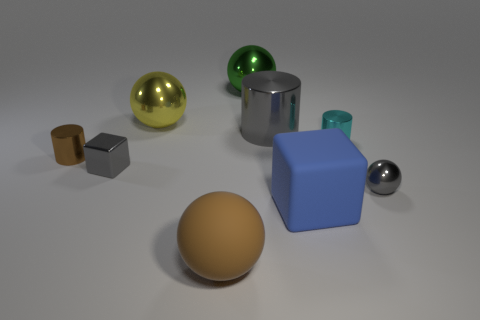There is a sphere that is the same color as the large shiny cylinder; what size is it?
Keep it short and to the point. Small. There is a small metallic ball; is its color the same as the cylinder to the left of the green metallic object?
Offer a very short reply. No. What number of things are either objects right of the gray metallic cube or metallic balls in front of the yellow object?
Provide a succinct answer. 7. There is a tiny gray metallic thing on the right side of the tiny cylinder that is behind the brown metallic cylinder; what shape is it?
Provide a succinct answer. Sphere. Is there a big yellow ball made of the same material as the big yellow object?
Offer a terse response. No. There is another large thing that is the same shape as the cyan thing; what is its color?
Offer a terse response. Gray. Are there fewer green spheres that are to the left of the small brown shiny thing than gray cylinders behind the big green shiny thing?
Ensure brevity in your answer.  No. What number of other objects are the same shape as the blue object?
Keep it short and to the point. 1. Is the number of cylinders left of the gray metal cylinder less than the number of large cyan metal objects?
Keep it short and to the point. No. What material is the ball in front of the big blue cube?
Offer a very short reply. Rubber. 